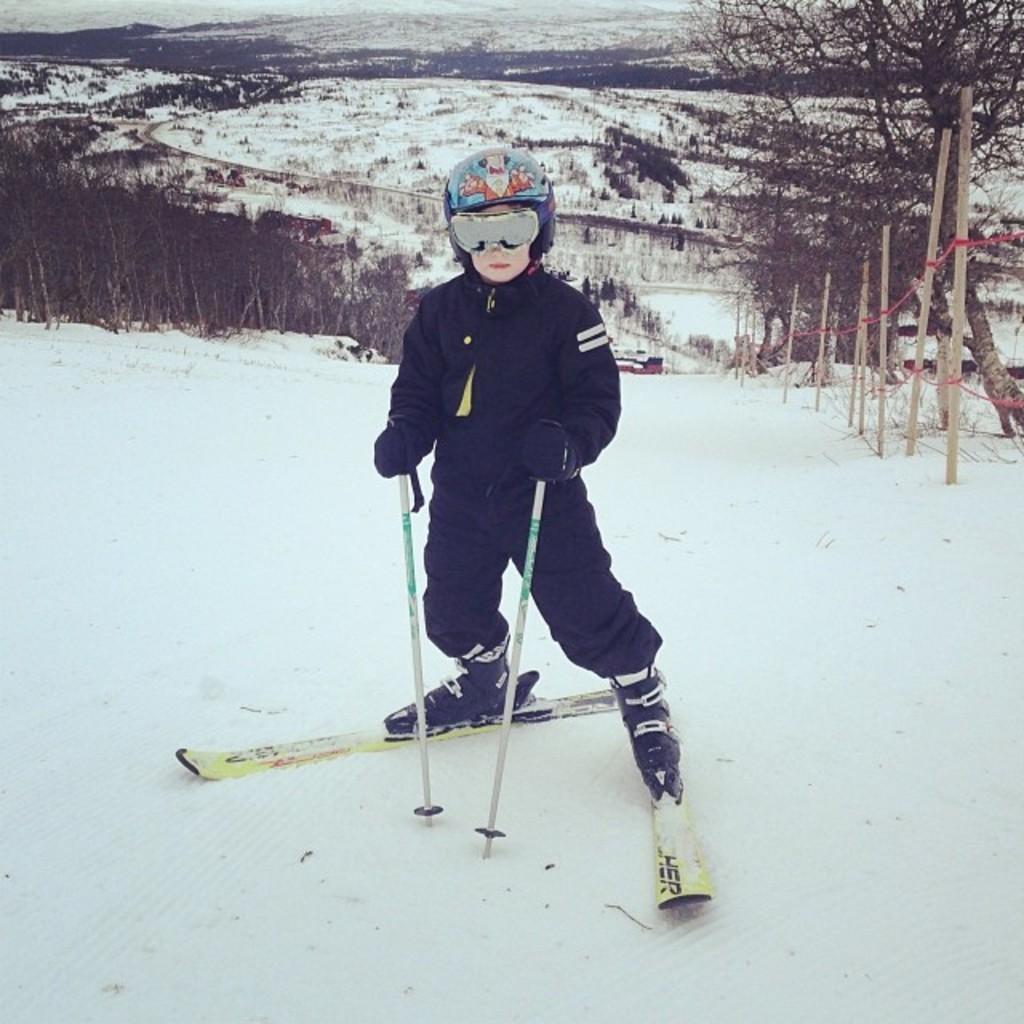In one or two sentences, can you explain what this image depicts? There is a child standing on the skiing boards with a two sticks in his hands. He is wearing helmet and spectacles. He is having gloves with his hands. He is standing on the snow with his skiing boards. There are some trees and in the background we can observe lot of land covered with the snow. There are some poles which are in the snow. 